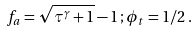Convert formula to latex. <formula><loc_0><loc_0><loc_500><loc_500>f _ { a } = \sqrt { \tau ^ { \gamma } + 1 } - 1 \, ; \phi _ { t } = 1 / 2 \, .</formula> 